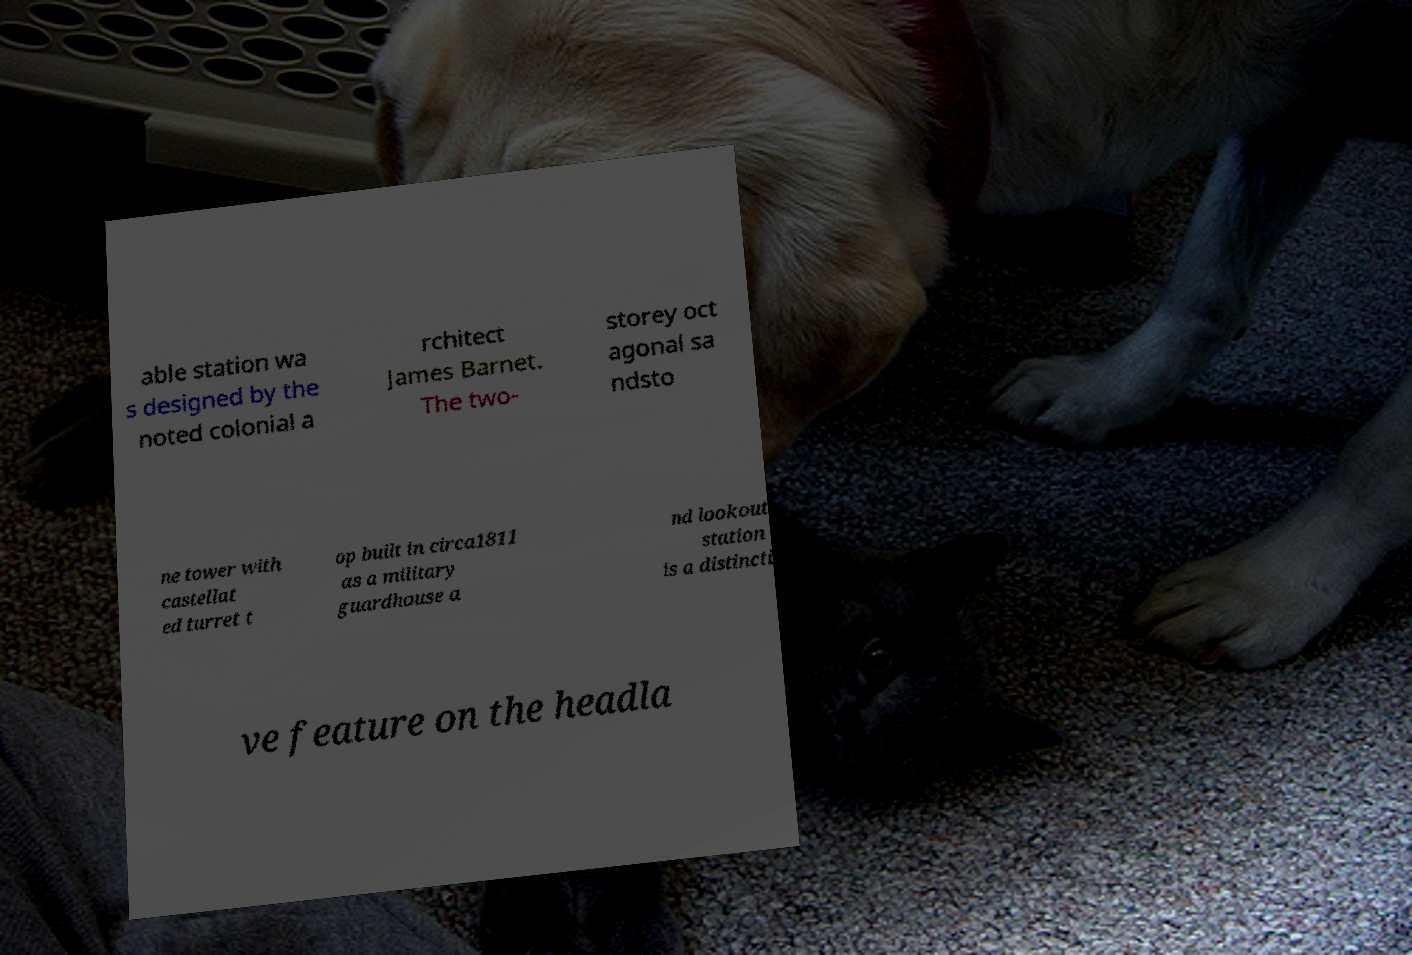I need the written content from this picture converted into text. Can you do that? able station wa s designed by the noted colonial a rchitect James Barnet. The two- storey oct agonal sa ndsto ne tower with castellat ed turret t op built in circa1811 as a military guardhouse a nd lookout station is a distincti ve feature on the headla 